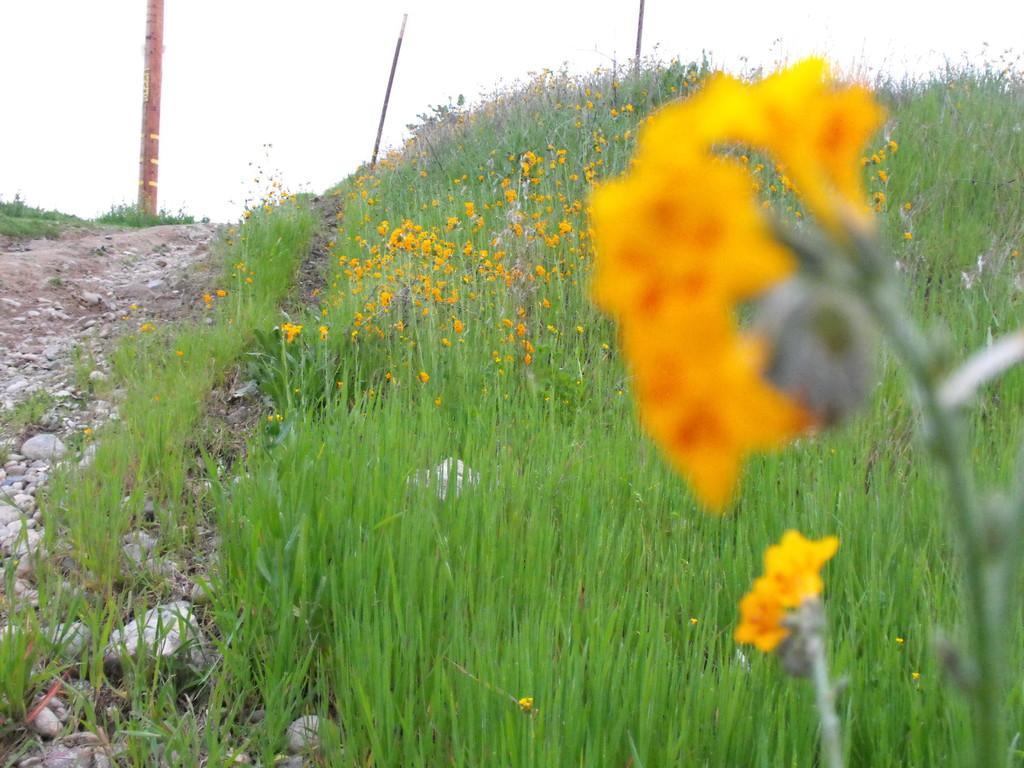Can you describe this image briefly? In the foreground I can see grass and flowering plants. In the background I can see a pole, stones and the sky. This image is taken during a day. 